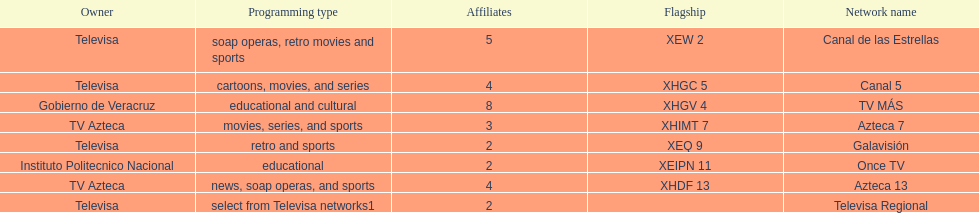How many networks display soap operas? 2. 